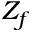Convert formula to latex. <formula><loc_0><loc_0><loc_500><loc_500>Z _ { f }</formula> 